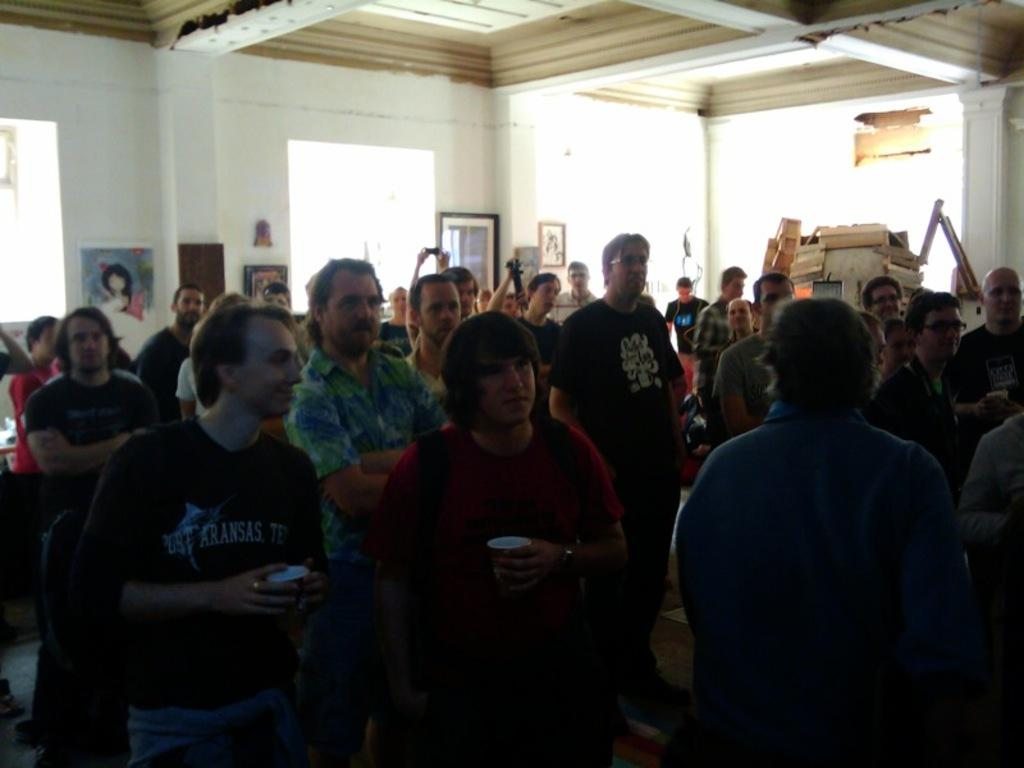How many people are in the image? There is a group of people in the image. What is the position of the people in the image? The people are standing on the floor. What can be seen in the background of the image? There is a wall with frames and other objects visible in the background of the image. What type of sense does the owl have in the image? There is no owl present in the image, so it is not possible to determine what type of sense it might have. 